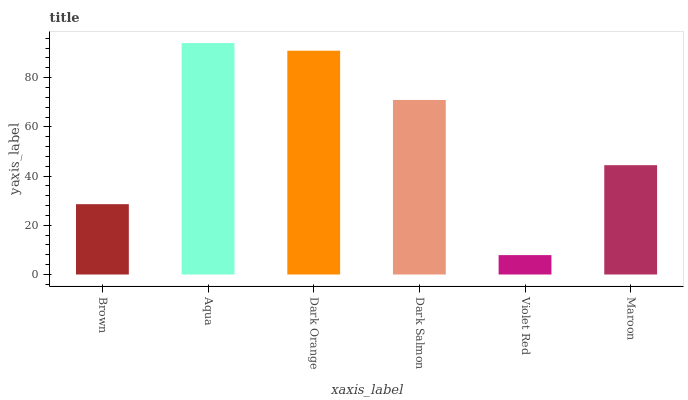Is Violet Red the minimum?
Answer yes or no. Yes. Is Aqua the maximum?
Answer yes or no. Yes. Is Dark Orange the minimum?
Answer yes or no. No. Is Dark Orange the maximum?
Answer yes or no. No. Is Aqua greater than Dark Orange?
Answer yes or no. Yes. Is Dark Orange less than Aqua?
Answer yes or no. Yes. Is Dark Orange greater than Aqua?
Answer yes or no. No. Is Aqua less than Dark Orange?
Answer yes or no. No. Is Dark Salmon the high median?
Answer yes or no. Yes. Is Maroon the low median?
Answer yes or no. Yes. Is Brown the high median?
Answer yes or no. No. Is Dark Salmon the low median?
Answer yes or no. No. 